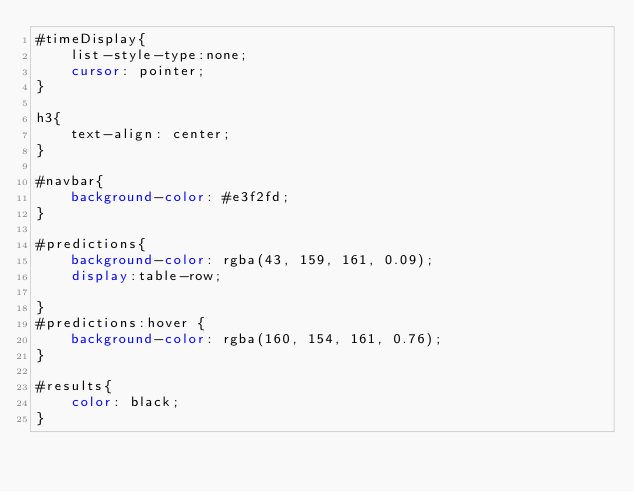Convert code to text. <code><loc_0><loc_0><loc_500><loc_500><_CSS_>#timeDisplay{
    list-style-type:none;
    cursor: pointer;
}

h3{
    text-align: center;
}

#navbar{
    background-color: #e3f2fd;
}

#predictions{
    background-color: rgba(43, 159, 161, 0.09);
    display:table-row;

}
#predictions:hover {
    background-color: rgba(160, 154, 161, 0.76);
}

#results{
    color: black;
}</code> 